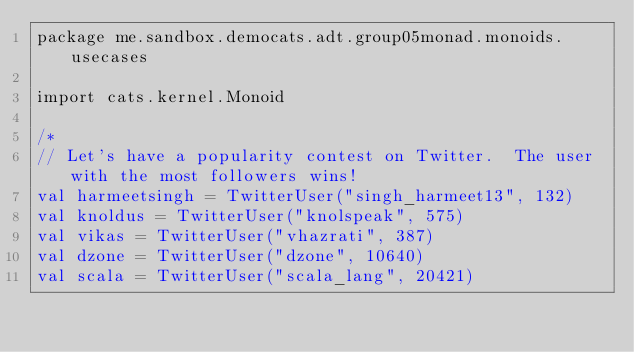<code> <loc_0><loc_0><loc_500><loc_500><_Scala_>package me.sandbox.democats.adt.group05monad.monoids.usecases

import cats.kernel.Monoid

/*
// Let's have a popularity contest on Twitter.  The user with the most followers wins!
val harmeetsingh = TwitterUser("singh_harmeet13", 132)
val knoldus = TwitterUser("knolspeak", 575)
val vikas = TwitterUser("vhazrati", 387)
val dzone = TwitterUser("dzone", 10640)
val scala = TwitterUser("scala_lang", 20421)
</code> 